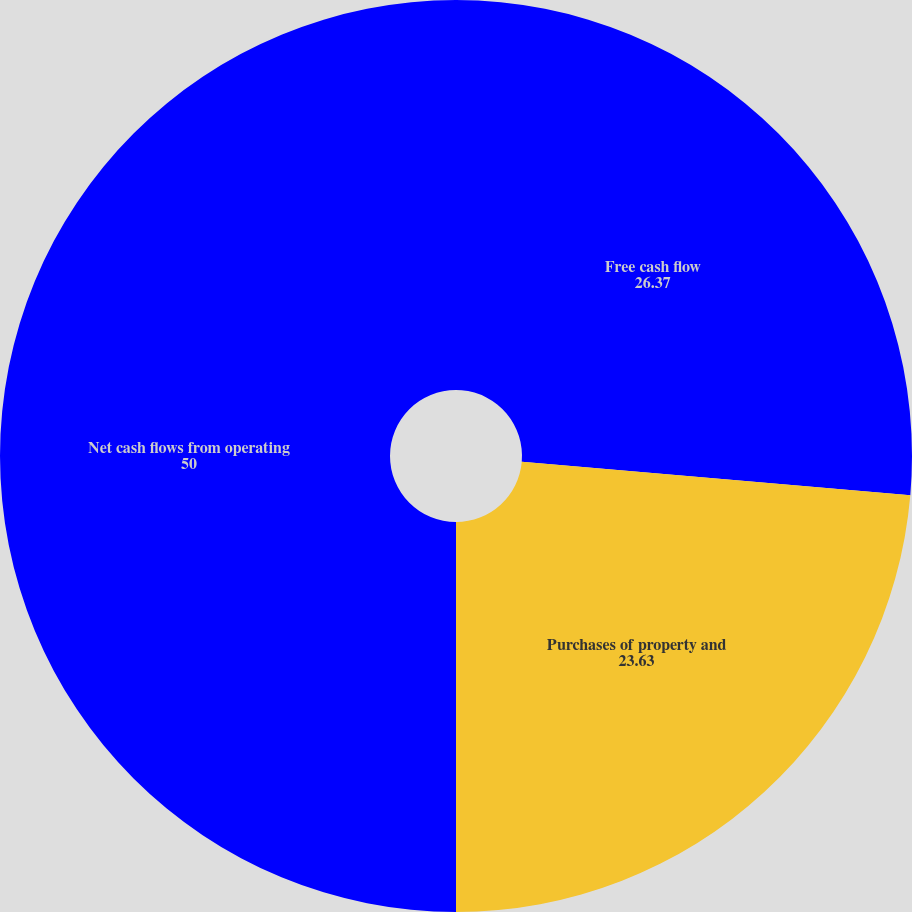Convert chart. <chart><loc_0><loc_0><loc_500><loc_500><pie_chart><fcel>Free cash flow<fcel>Purchases of property and<fcel>Net cash flows from operating<nl><fcel>26.37%<fcel>23.63%<fcel>50.0%<nl></chart> 